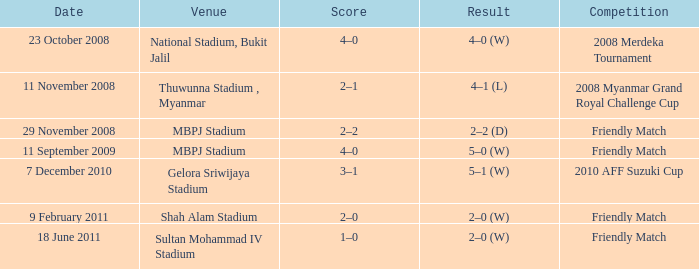How did the match at gelora sriwijaya stadium end in terms of score? 3–1. 